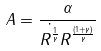Convert formula to latex. <formula><loc_0><loc_0><loc_500><loc_500>A = \frac { \alpha } { \dot { R ^ { \frac { 1 } { \gamma } } } R ^ { \frac { ( 1 + \gamma ) } { \gamma } } }</formula> 